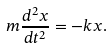<formula> <loc_0><loc_0><loc_500><loc_500>m \frac { d ^ { 2 } x } { d t ^ { 2 } } = - k x .</formula> 